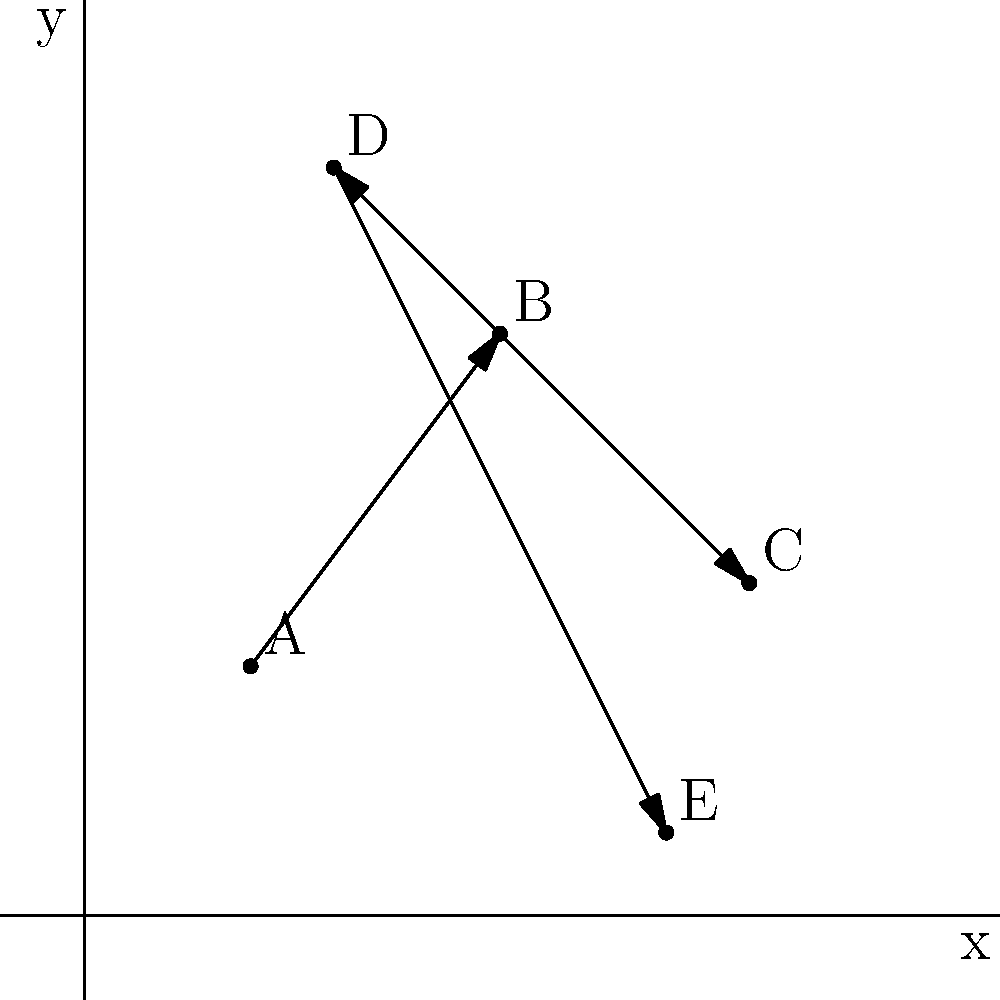In your study of ancient trade routes, you've plotted five major cities on a coordinate plane. City A is at (2,3), B at (5,7), C at (8,4), D at (3,9), and E at (7,1). Traders typically followed the route A → B → C → D → E. Calculate the total distance traveled along this trade route using the distance formula. Round your answer to the nearest whole number. To solve this problem, we'll use the distance formula between two points: $d = \sqrt{(x_2-x_1)^2 + (y_2-y_1)^2}$

Let's calculate the distance for each segment of the route:

1. A to B: $d_{AB} = \sqrt{(5-2)^2 + (7-3)^2} = \sqrt{3^2 + 4^2} = \sqrt{9 + 16} = \sqrt{25} = 5$

2. B to C: $d_{BC} = \sqrt{(8-5)^2 + (4-7)^2} = \sqrt{3^2 + (-3)^2} = \sqrt{9 + 9} = \sqrt{18} \approx 4.24$

3. C to D: $d_{CD} = \sqrt{(3-8)^2 + (9-4)^2} = \sqrt{(-5)^2 + 5^2} = \sqrt{25 + 25} = \sqrt{50} \approx 7.07$

4. D to E: $d_{DE} = \sqrt{(7-3)^2 + (1-9)^2} = \sqrt{4^2 + (-8)^2} = \sqrt{16 + 64} = \sqrt{80} \approx 8.94$

Now, we sum up all these distances:

Total distance = $5 + 4.24 + 7.07 + 8.94 = 25.25$

Rounding to the nearest whole number: 25
Answer: 25 units 